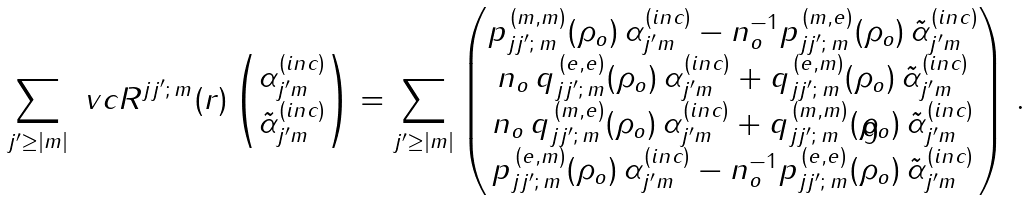<formula> <loc_0><loc_0><loc_500><loc_500>\sum _ { j ^ { \prime } \geq | m | } \ v c { R } ^ { j j ^ { \prime } ; \, m } ( r ) \begin{pmatrix} \alpha _ { j ^ { \prime } m } ^ { ( i n c ) } \\ \tilde { \alpha } _ { j ^ { \prime } m } ^ { ( i n c ) } \end{pmatrix} = \sum _ { j ^ { \prime } \geq | m | } \begin{pmatrix} p _ { j j ^ { \prime } ; \, m } ^ { \, ( m , m ) } ( \rho _ { o } ) \, \alpha _ { j ^ { \prime } m } ^ { ( i n c ) } - n _ { o } ^ { - 1 } p _ { j j ^ { \prime } ; \, m } ^ { \, ( m , e ) } ( \rho _ { o } ) \, \tilde { \alpha } _ { j ^ { \prime } m } ^ { ( i n c ) } \\ n _ { o } \, q _ { j j ^ { \prime } ; \, m } ^ { \, ( e , e ) } ( \rho _ { o } ) \, \alpha _ { j ^ { \prime } m } ^ { ( i n c ) } + q _ { j j ^ { \prime } ; \, m } ^ { \, ( e , m ) } ( \rho _ { o } ) \, \tilde { \alpha } _ { j ^ { \prime } m } ^ { ( i n c ) } \\ n _ { o } \, q _ { j j ^ { \prime } ; \, m } ^ { \, ( m , e ) } ( \rho _ { o } ) \, \alpha _ { j ^ { \prime } m } ^ { ( i n c ) } + q _ { j j ^ { \prime } ; \, m } ^ { \, ( m , m ) } ( \rho _ { o } ) \, \tilde { \alpha } _ { j ^ { \prime } m } ^ { ( i n c ) } \\ p _ { j j ^ { \prime } ; \, m } ^ { \, ( e , m ) } ( \rho _ { o } ) \, \alpha _ { j ^ { \prime } m } ^ { ( i n c ) } - n _ { o } ^ { - 1 } p _ { j j ^ { \prime } ; \, m } ^ { \, ( e , e ) } ( \rho _ { o } ) \, \tilde { \alpha } _ { j ^ { \prime } m } ^ { ( i n c ) } \end{pmatrix} \, .</formula> 